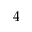Convert formula to latex. <formula><loc_0><loc_0><loc_500><loc_500>4</formula> 